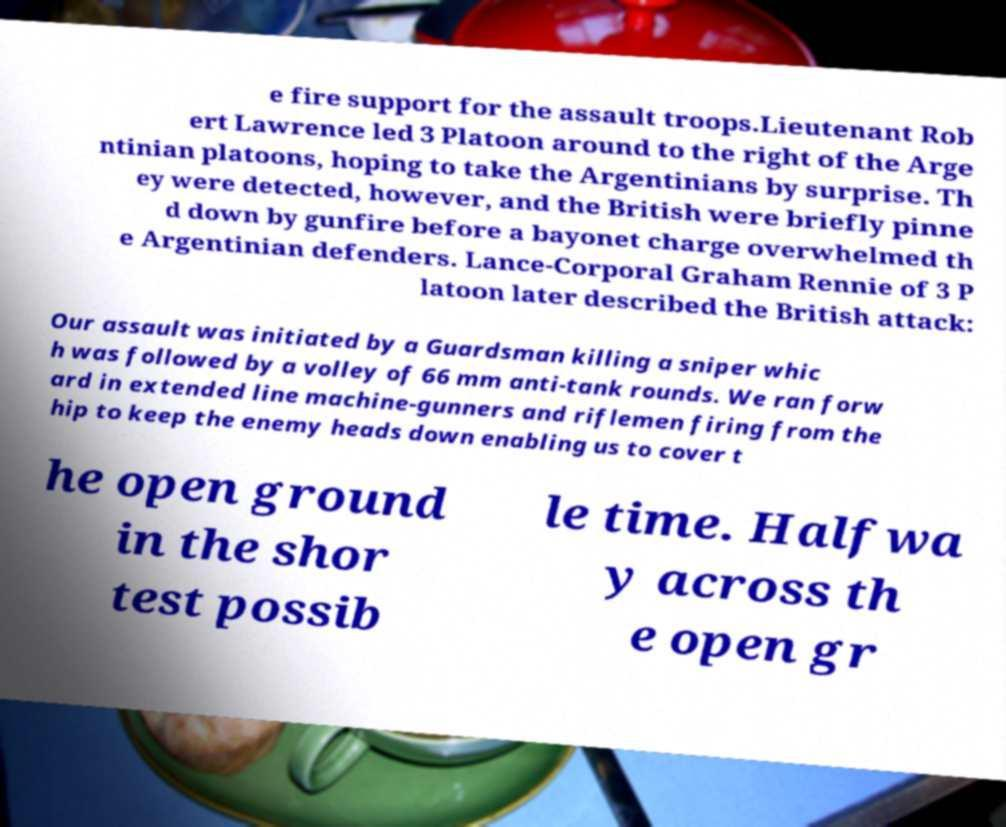Could you assist in decoding the text presented in this image and type it out clearly? e fire support for the assault troops.Lieutenant Rob ert Lawrence led 3 Platoon around to the right of the Arge ntinian platoons, hoping to take the Argentinians by surprise. Th ey were detected, however, and the British were briefly pinne d down by gunfire before a bayonet charge overwhelmed th e Argentinian defenders. Lance-Corporal Graham Rennie of 3 P latoon later described the British attack: Our assault was initiated by a Guardsman killing a sniper whic h was followed by a volley of 66 mm anti-tank rounds. We ran forw ard in extended line machine-gunners and riflemen firing from the hip to keep the enemy heads down enabling us to cover t he open ground in the shor test possib le time. Halfwa y across th e open gr 